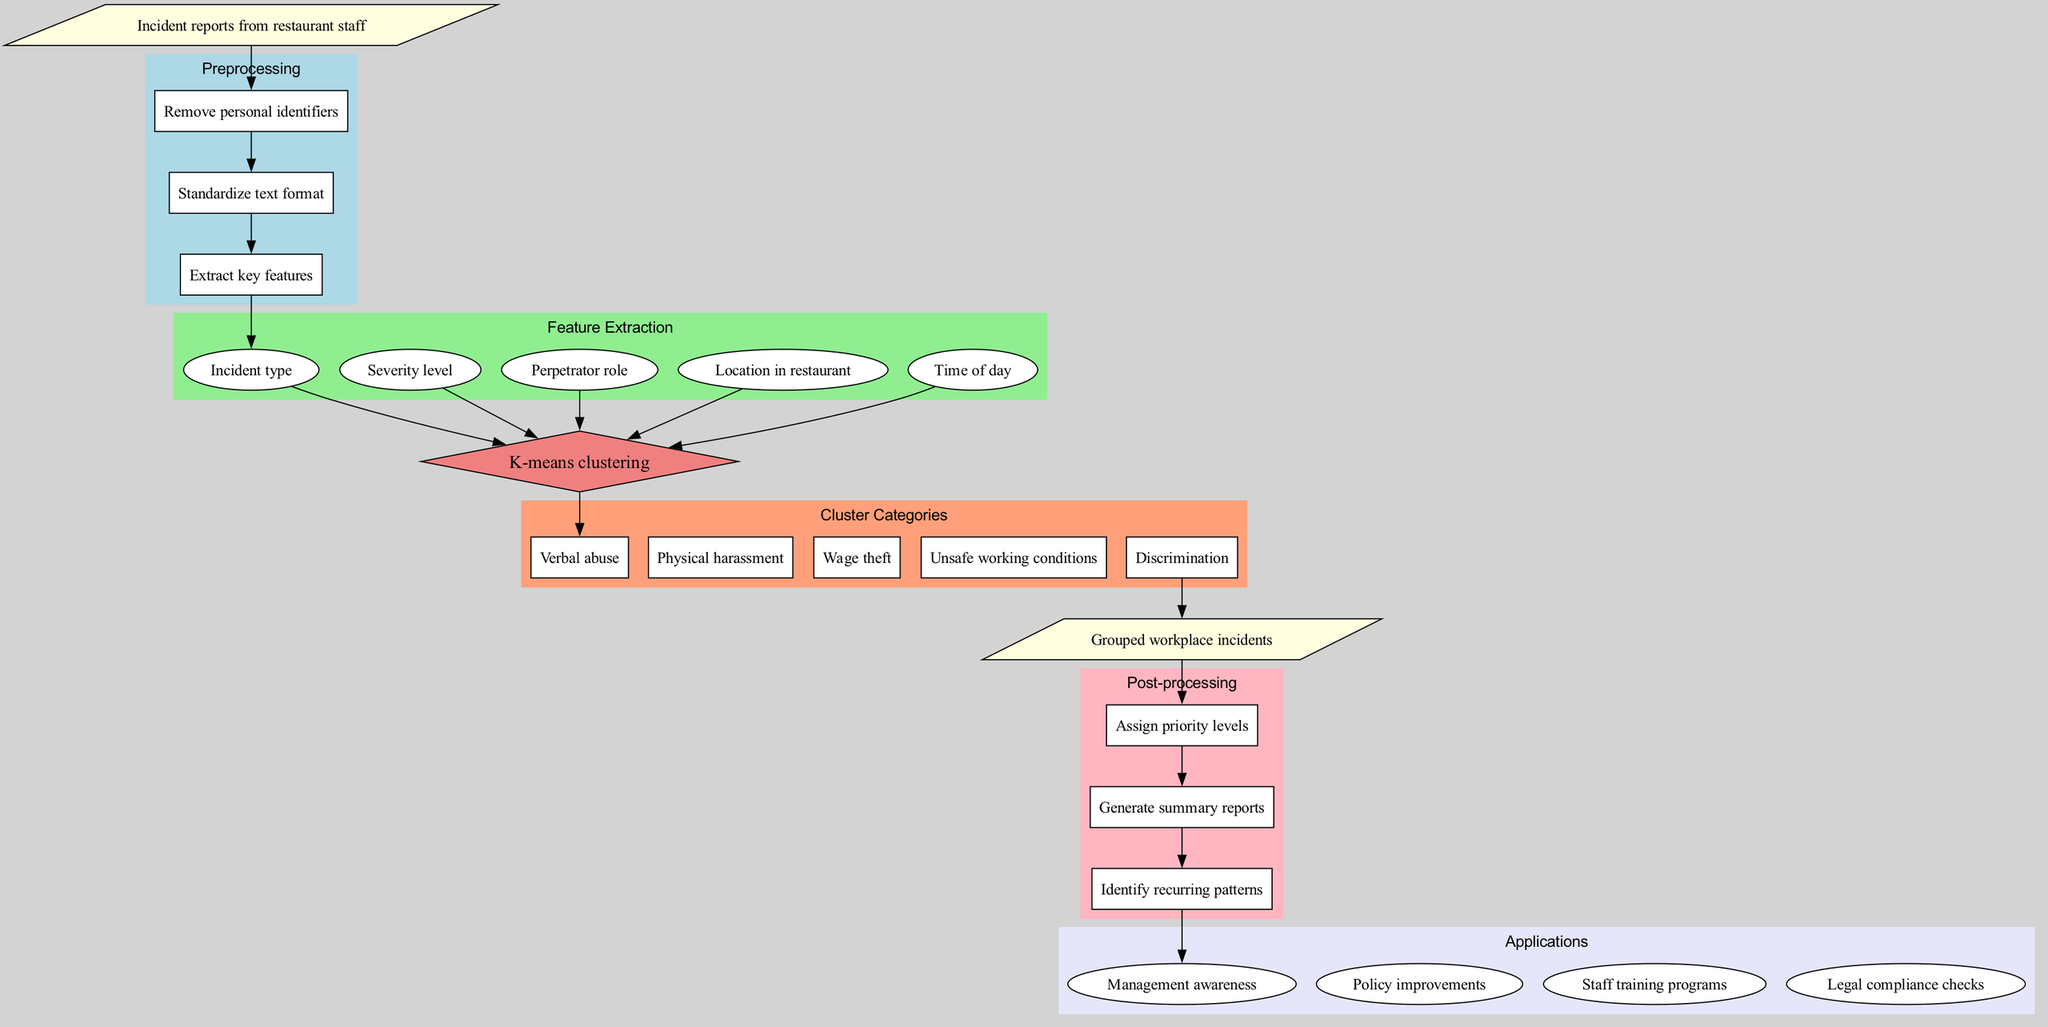What is the input data for this diagram? The input data is specified at the starting point of the diagram as "Incident reports from restaurant staff." This is a straightforward retrieval of information directly from the input node.
Answer: Incident reports from restaurant staff How many preprocessing steps are shown in the diagram? The preprocessing section contains three steps: Remove personal identifiers, Standardize text format, and Extract key features. By counting these items, we can conclude that there are three steps.
Answer: 3 What is the clustering algorithm used in this diagram? The algorithm is indicated as K-means clustering in the clustering algorithm node. This is a direct retrieval from the node's label.
Answer: K-means clustering What are the cluster categories listed in the diagram? The categories are shown in the "Cluster Categories" section, which lists five types: Verbal abuse, Physical harassment, Wage theft, Unsafe working conditions, and Discrimination. These are explicitly stated and can be retrieved as a group.
Answer: Verbal abuse, Physical harassment, Wage theft, Unsafe working conditions, Discrimination What is the first post-processing step in the diagram? The post-processing section begins with "Assign priority levels," which is the first item listed in that part of the diagram. This is simply retrieved from the order of steps shown.
Answer: Assign priority levels Which application aims to improve policy measures? The application related to policy is "Policy improvements." It is listed under the applications section, making it easily identifiable and directly answerable.
Answer: Policy improvements What is the output of this diagram? The output node states "Grouped workplace incidents," which summarizes what the diagram ultimately produces after processing the input data and applying the algorithm. This is pulled directly from the output node.
Answer: Grouped workplace incidents How many features are extracted in the feature extraction phase? The feature extraction phase lists five specific features: Incident type, Severity level, Perpetrator role, Location in restaurant, and Time of day. Thus, there are five features extracted as indicated in that part of the diagram.
Answer: 5 What does the algorithm receive as input? The algorithm receives features extracted during the feature extraction phase, indicated by the edges connecting the features to the algorithm. This shows the process flow leading into the algorithm, so it clearly receives the five extracted features.
Answer: Features extracted 